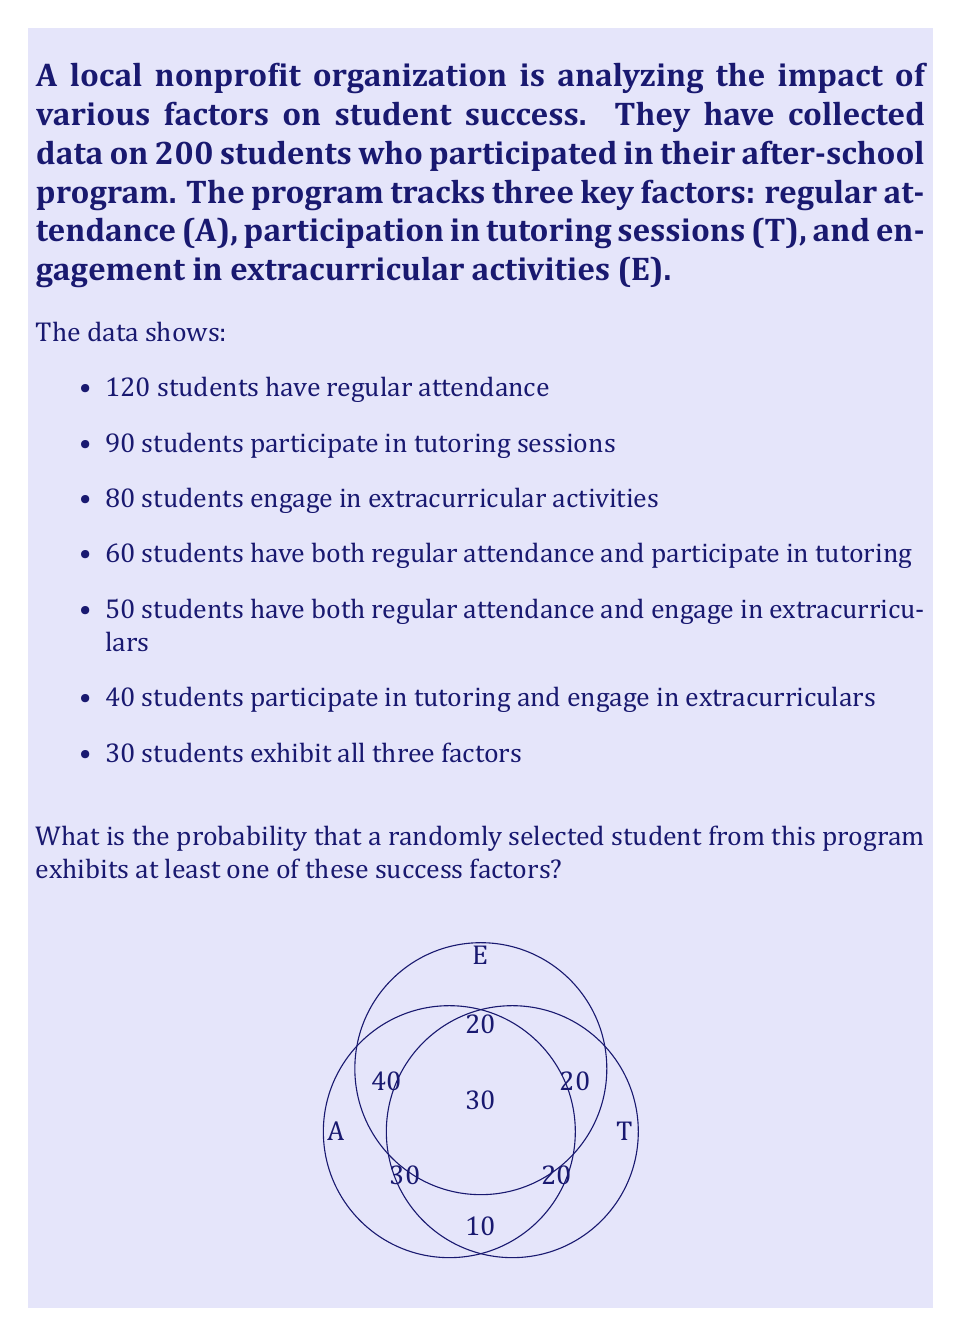What is the answer to this math problem? To solve this problem, we'll use the Inclusion-Exclusion Principle for three sets.

Let's define our sets:
A: Students with regular attendance
T: Students who participate in tutoring sessions
E: Students who engage in extracurricular activities

We're given:
|A| = 120, |T| = 90, |E| = 80
|A ∩ T| = 60, |A ∩ E| = 50, |T ∩ E| = 40
|A ∩ T ∩ E| = 30

Step 1: Calculate |A ∪ T ∪ E| using the Inclusion-Exclusion Principle:
$$ |A ∪ T ∪ E| = |A| + |T| + |E| - |A ∩ T| - |A ∩ E| - |T ∩ E| + |A ∩ T ∩ E| $$

Step 2: Substitute the given values:
$$ |A ∪ T ∪ E| = 120 + 90 + 80 - 60 - 50 - 40 + 30 = 170 $$

Step 3: Calculate the probability of a student exhibiting at least one success factor:
$$ P(\text{at least one factor}) = \frac{|A ∪ T ∪ E|}{\text{Total students}} = \frac{170}{200} = 0.85 $$

Therefore, the probability that a randomly selected student exhibits at least one of these success factors is 0.85 or 85%.
Answer: 0.85 